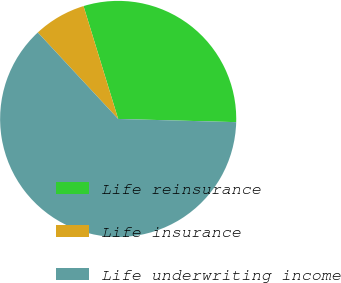<chart> <loc_0><loc_0><loc_500><loc_500><pie_chart><fcel>Life reinsurance<fcel>Life insurance<fcel>Life underwriting income<nl><fcel>30.17%<fcel>7.18%<fcel>62.64%<nl></chart> 